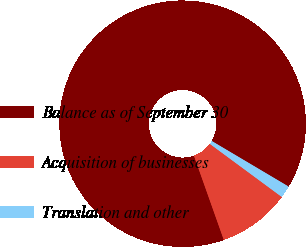<chart> <loc_0><loc_0><loc_500><loc_500><pie_chart><fcel>Balance as of September 30<fcel>Acquisition of businesses<fcel>Translation and other<nl><fcel>88.94%<fcel>9.46%<fcel>1.6%<nl></chart> 